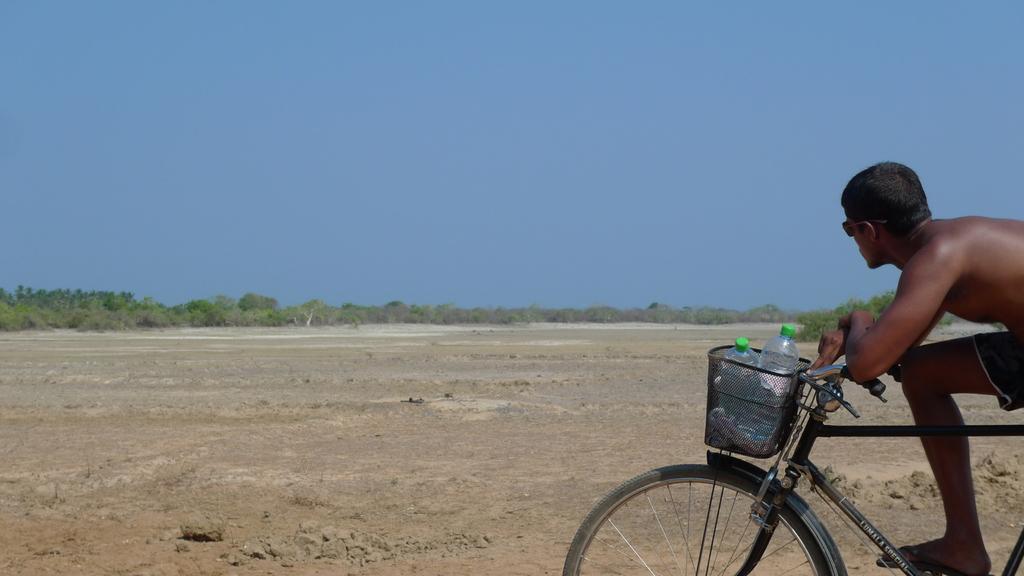Could you give a brief overview of what you see in this image? In this image i can see a man on a bicycle there are two bottles in a basket at the back ground i can see a tree and a sky. 